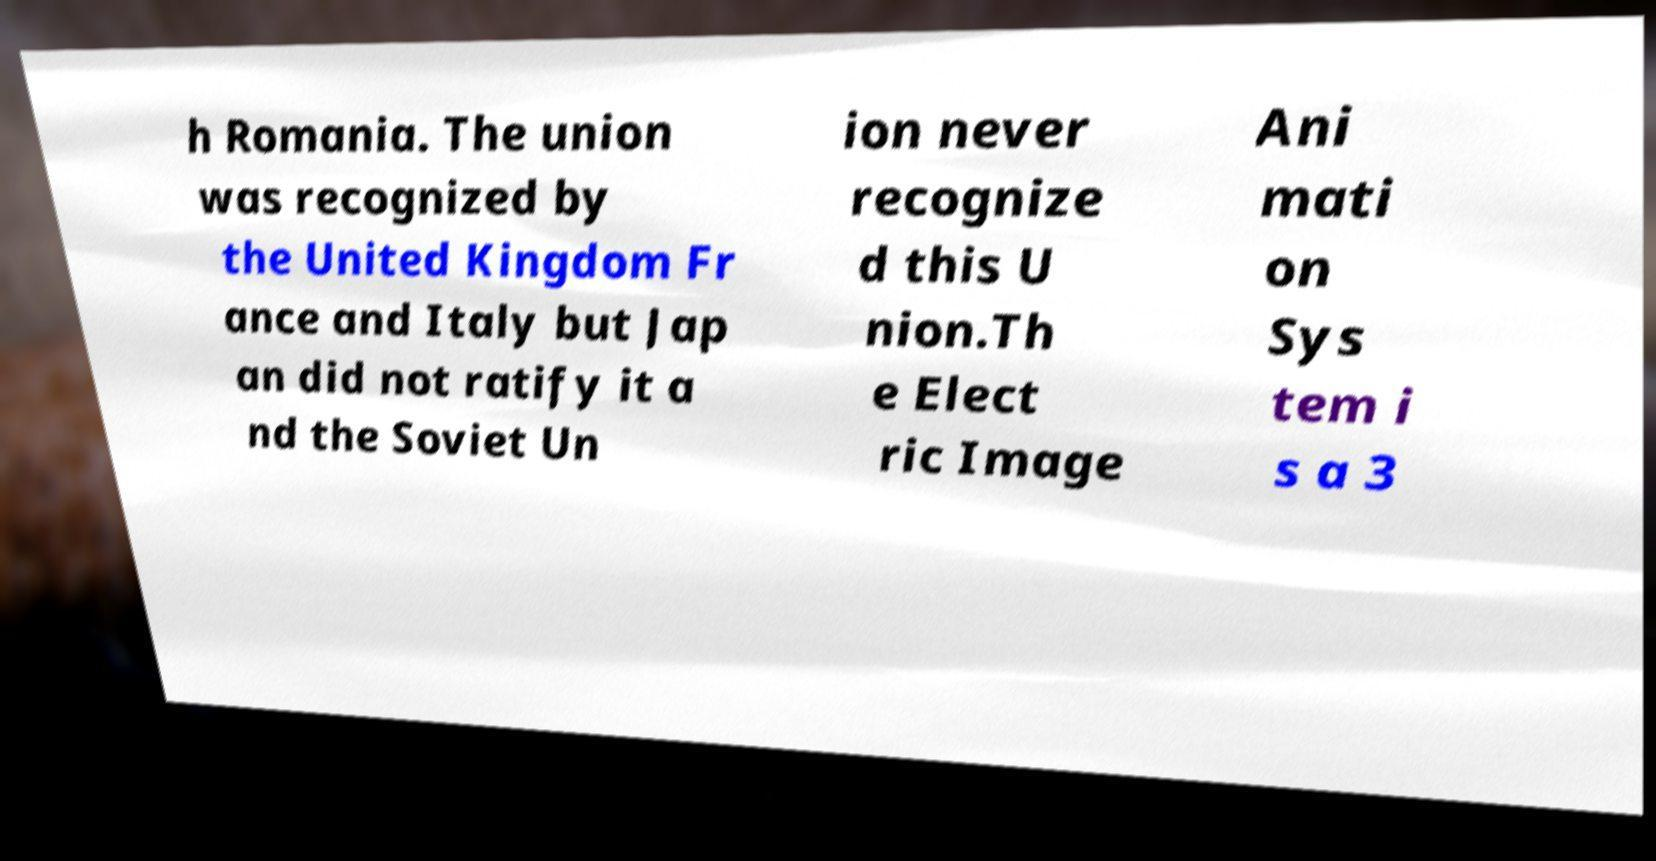Can you accurately transcribe the text from the provided image for me? h Romania. The union was recognized by the United Kingdom Fr ance and Italy but Jap an did not ratify it a nd the Soviet Un ion never recognize d this U nion.Th e Elect ric Image Ani mati on Sys tem i s a 3 